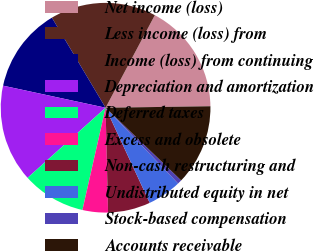Convert chart. <chart><loc_0><loc_0><loc_500><loc_500><pie_chart><fcel>Net income (loss)<fcel>Less income (loss) from<fcel>Income (loss) from continuing<fcel>Depreciation and amortization<fcel>Deferred taxes<fcel>Excess and obsolete<fcel>Non-cash restructuring and<fcel>Undistributed equity in net<fcel>Stock-based compensation<fcel>Accounts receivable<nl><fcel>16.99%<fcel>16.34%<fcel>13.07%<fcel>15.03%<fcel>9.8%<fcel>3.92%<fcel>6.54%<fcel>5.23%<fcel>0.66%<fcel>12.42%<nl></chart> 